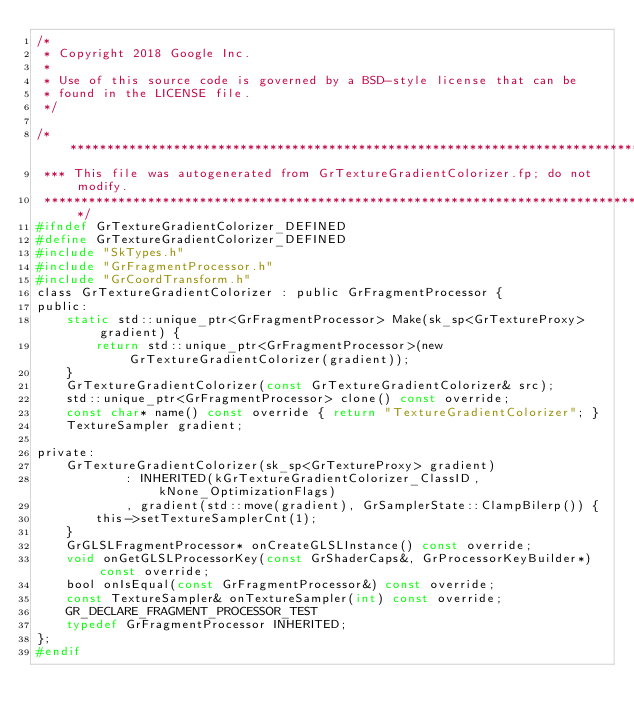<code> <loc_0><loc_0><loc_500><loc_500><_C_>/*
 * Copyright 2018 Google Inc.
 *
 * Use of this source code is governed by a BSD-style license that can be
 * found in the LICENSE file.
 */

/**************************************************************************************************
 *** This file was autogenerated from GrTextureGradientColorizer.fp; do not modify.
 **************************************************************************************************/
#ifndef GrTextureGradientColorizer_DEFINED
#define GrTextureGradientColorizer_DEFINED
#include "SkTypes.h"
#include "GrFragmentProcessor.h"
#include "GrCoordTransform.h"
class GrTextureGradientColorizer : public GrFragmentProcessor {
public:
    static std::unique_ptr<GrFragmentProcessor> Make(sk_sp<GrTextureProxy> gradient) {
        return std::unique_ptr<GrFragmentProcessor>(new GrTextureGradientColorizer(gradient));
    }
    GrTextureGradientColorizer(const GrTextureGradientColorizer& src);
    std::unique_ptr<GrFragmentProcessor> clone() const override;
    const char* name() const override { return "TextureGradientColorizer"; }
    TextureSampler gradient;

private:
    GrTextureGradientColorizer(sk_sp<GrTextureProxy> gradient)
            : INHERITED(kGrTextureGradientColorizer_ClassID, kNone_OptimizationFlags)
            , gradient(std::move(gradient), GrSamplerState::ClampBilerp()) {
        this->setTextureSamplerCnt(1);
    }
    GrGLSLFragmentProcessor* onCreateGLSLInstance() const override;
    void onGetGLSLProcessorKey(const GrShaderCaps&, GrProcessorKeyBuilder*) const override;
    bool onIsEqual(const GrFragmentProcessor&) const override;
    const TextureSampler& onTextureSampler(int) const override;
    GR_DECLARE_FRAGMENT_PROCESSOR_TEST
    typedef GrFragmentProcessor INHERITED;
};
#endif
</code> 